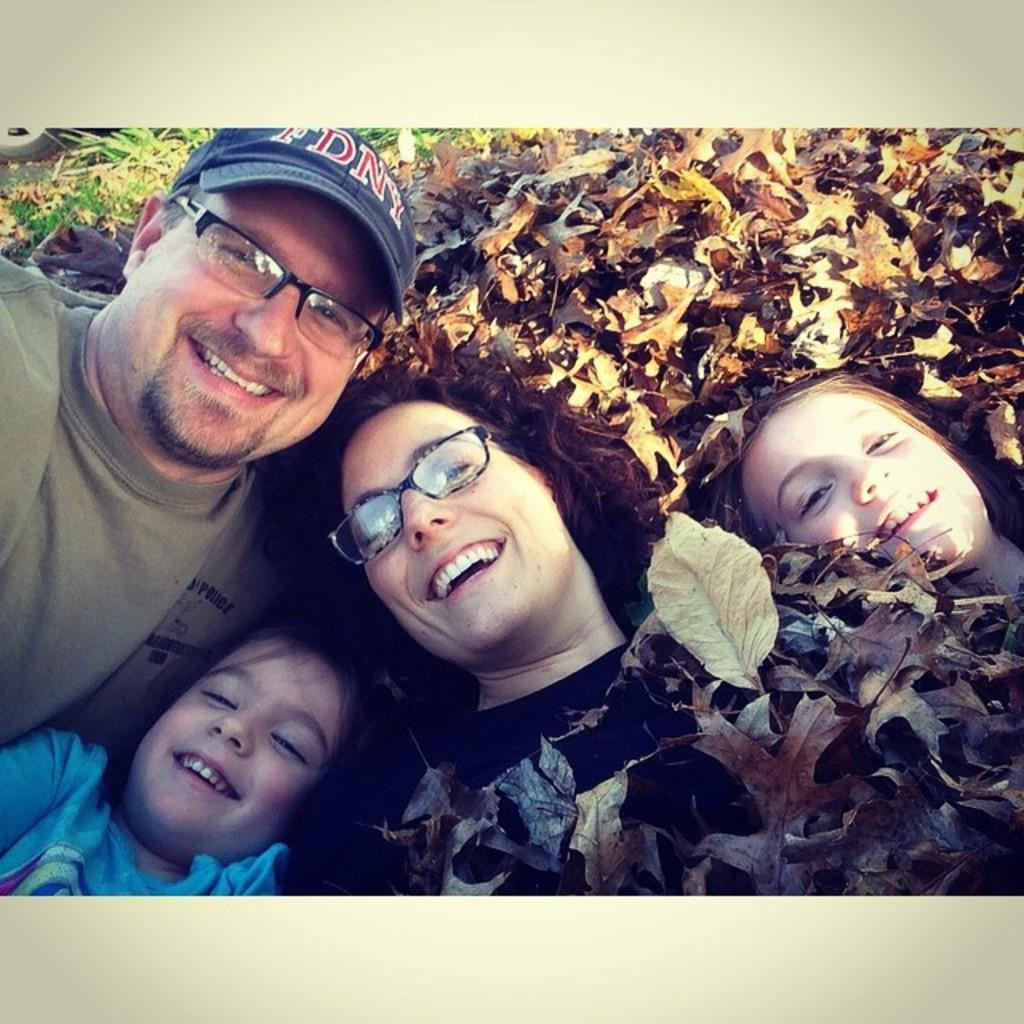Who or what is present in the image? There are people in the image. What are the people doing in the image? The people are smiling. What can be seen in the background of the image? There are plants in the background of the image. What type of bean is being used as a prop in the image? There is no bean present in the image. What role does the manager play in the image? There is no mention of a manager in the image or the provided facts. 